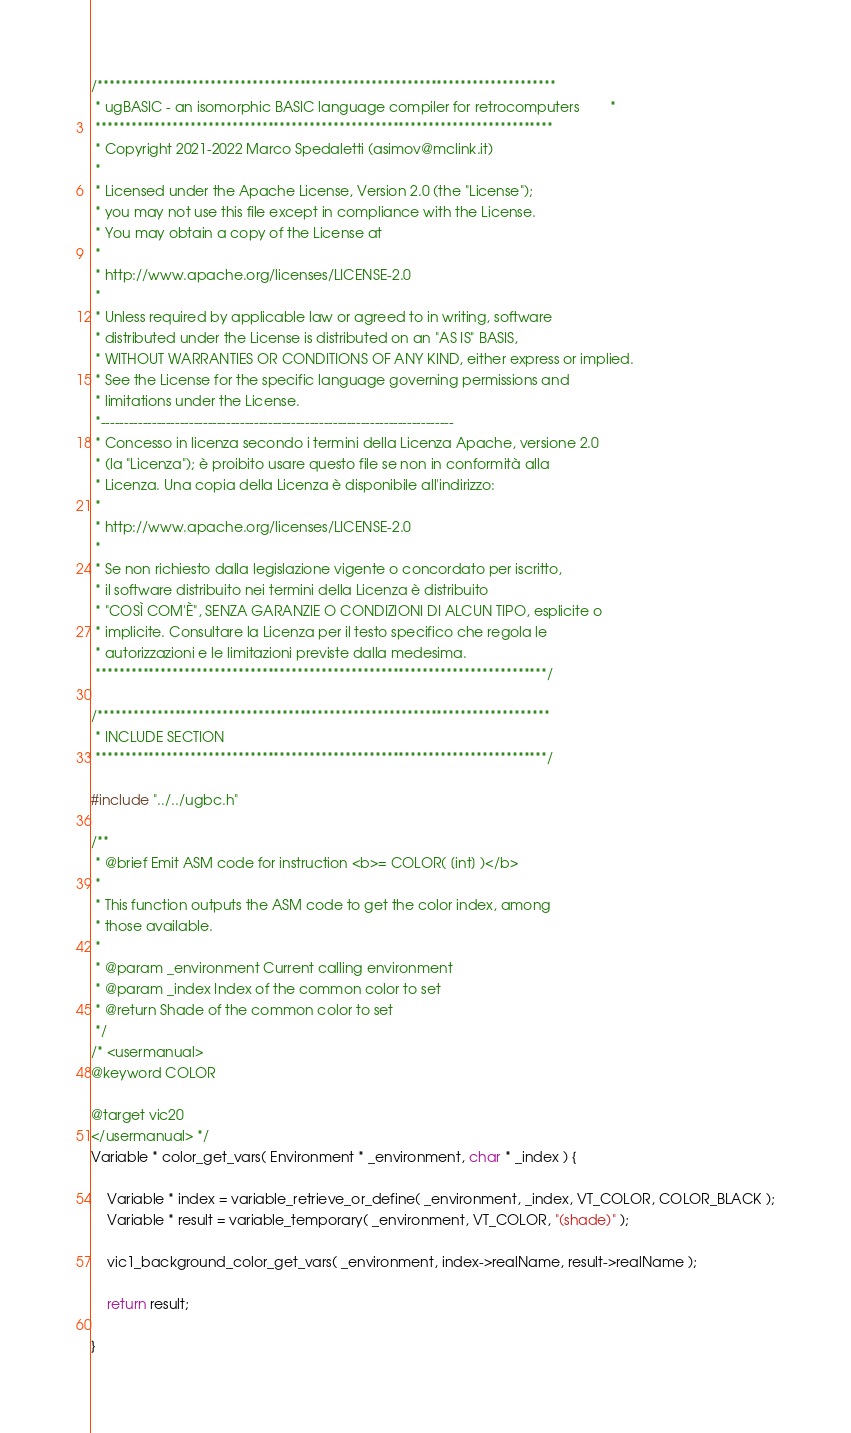<code> <loc_0><loc_0><loc_500><loc_500><_C_>/*****************************************************************************
 * ugBASIC - an isomorphic BASIC language compiler for retrocomputers        *
 *****************************************************************************
 * Copyright 2021-2022 Marco Spedaletti (asimov@mclink.it)
 *
 * Licensed under the Apache License, Version 2.0 (the "License");
 * you may not use this file except in compliance with the License.
 * You may obtain a copy of the License at
 *
 * http://www.apache.org/licenses/LICENSE-2.0
 *
 * Unless required by applicable law or agreed to in writing, software
 * distributed under the License is distributed on an "AS IS" BASIS,
 * WITHOUT WARRANTIES OR CONDITIONS OF ANY KIND, either express or implied.
 * See the License for the specific language governing permissions and
 * limitations under the License.
 *----------------------------------------------------------------------------
 * Concesso in licenza secondo i termini della Licenza Apache, versione 2.0
 * (la "Licenza"); è proibito usare questo file se non in conformità alla
 * Licenza. Una copia della Licenza è disponibile all'indirizzo:
 *
 * http://www.apache.org/licenses/LICENSE-2.0
 *
 * Se non richiesto dalla legislazione vigente o concordato per iscritto,
 * il software distribuito nei termini della Licenza è distribuito
 * "COSÌ COM'È", SENZA GARANZIE O CONDIZIONI DI ALCUN TIPO, esplicite o
 * implicite. Consultare la Licenza per il testo specifico che regola le
 * autorizzazioni e le limitazioni previste dalla medesima.
 ****************************************************************************/

/****************************************************************************
 * INCLUDE SECTION 
 ****************************************************************************/

#include "../../ugbc.h"

/**
 * @brief Emit ASM code for instruction <b>= COLOR( [int] )</b>
 * 
 * This function outputs the ASM code to get the color index, among 
 * those available.
 * 
 * @param _environment Current calling environment
 * @param _index Index of the common color to set
 * @return Shade of the common color to set
 */
/* <usermanual>
@keyword COLOR

@target vic20
</usermanual> */
Variable * color_get_vars( Environment * _environment, char * _index ) {

    Variable * index = variable_retrieve_or_define( _environment, _index, VT_COLOR, COLOR_BLACK );
    Variable * result = variable_temporary( _environment, VT_COLOR, "(shade)" );

    vic1_background_color_get_vars( _environment, index->realName, result->realName );

    return result;
    
}
</code> 